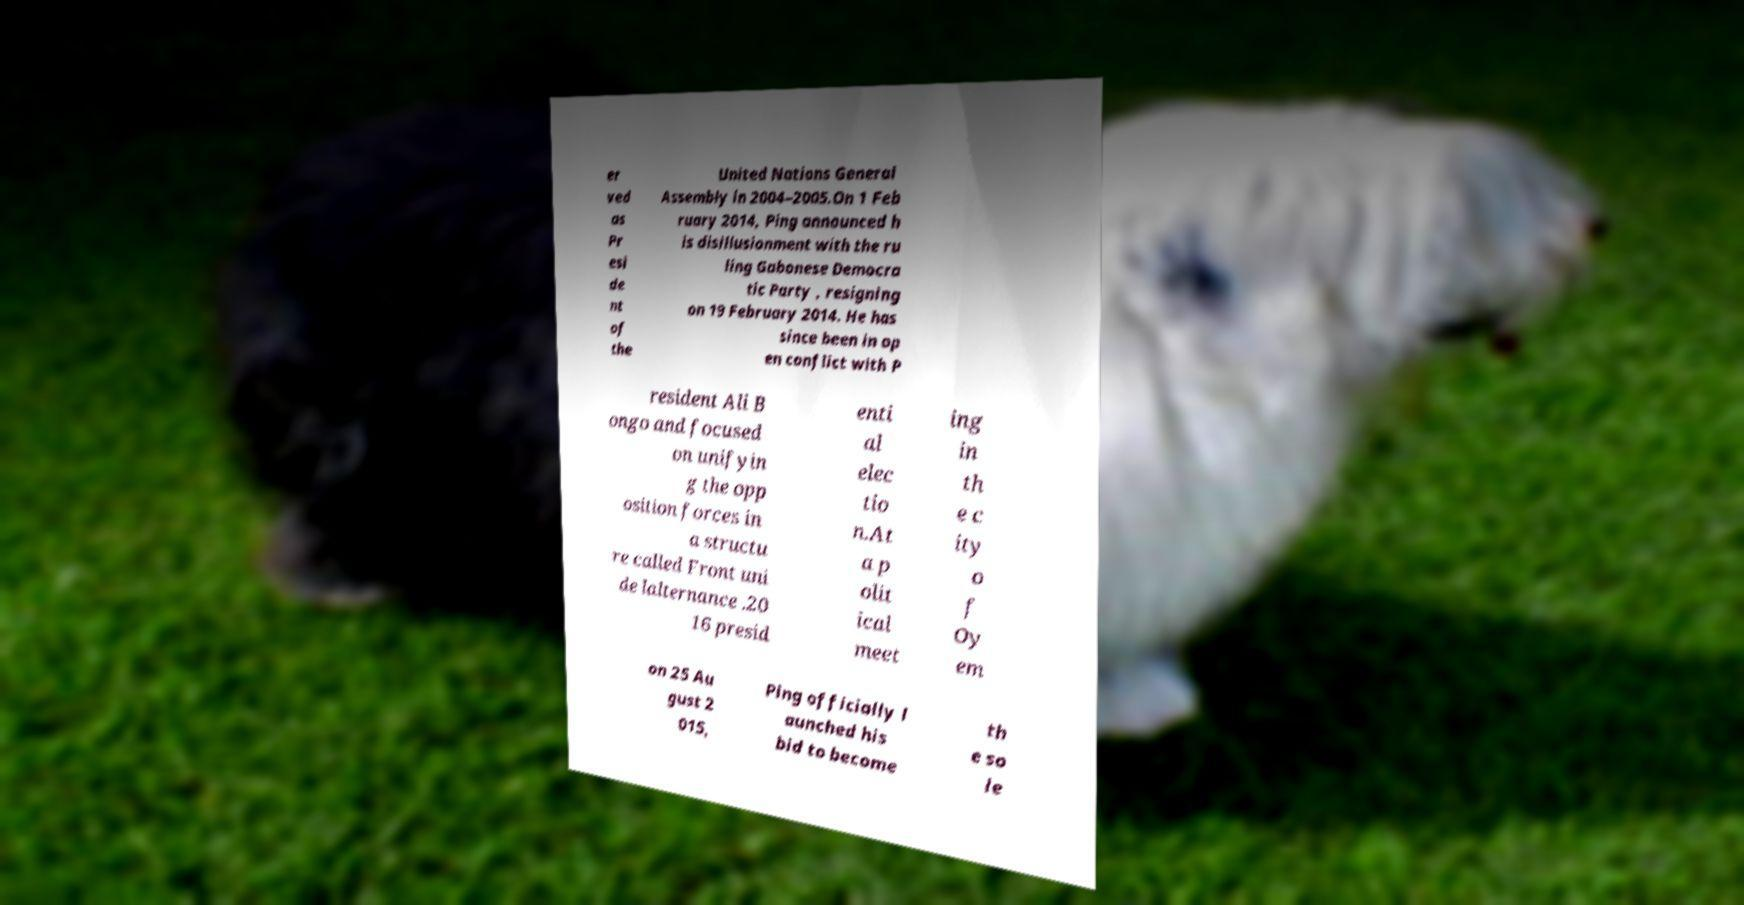There's text embedded in this image that I need extracted. Can you transcribe it verbatim? er ved as Pr esi de nt of the United Nations General Assembly in 2004–2005.On 1 Feb ruary 2014, Ping announced h is disillusionment with the ru ling Gabonese Democra tic Party , resigning on 19 February 2014. He has since been in op en conflict with P resident Ali B ongo and focused on unifyin g the opp osition forces in a structu re called Front uni de lalternance .20 16 presid enti al elec tio n.At a p olit ical meet ing in th e c ity o f Oy em on 25 Au gust 2 015, Ping officially l aunched his bid to become th e so le 